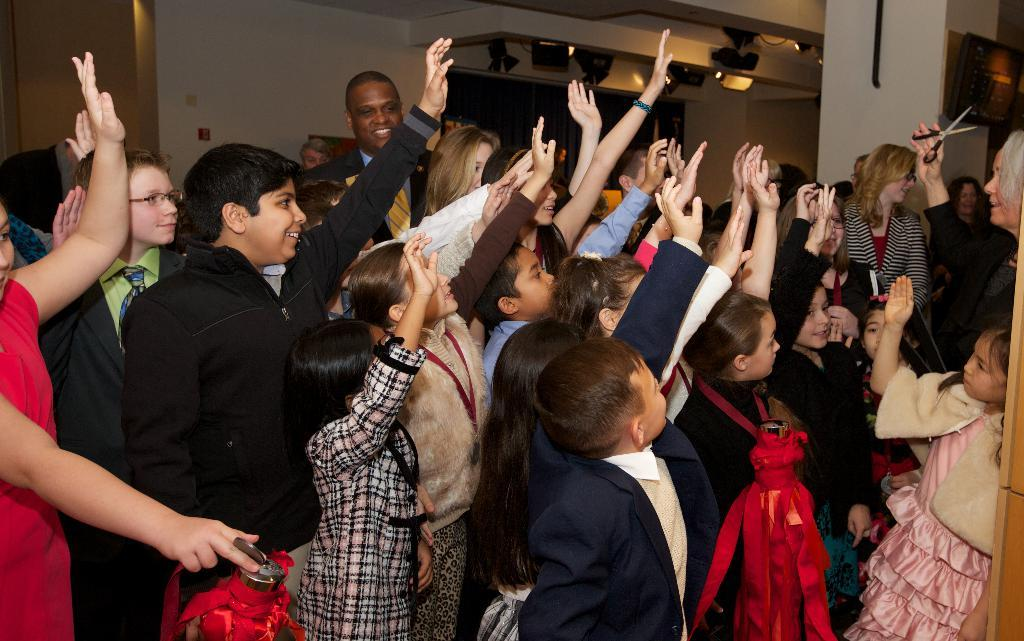How many people are in the image? There is a group of people in the image. What object is being held by one of the people? Scissors are being held in a hand. What can be seen in the background of the image? There are lights and a wall visible in the background of the image. How far away is the railway from the group of people in the image? There is no railway present in the image, so it is not possible to determine the distance between the group of people and a railway. 